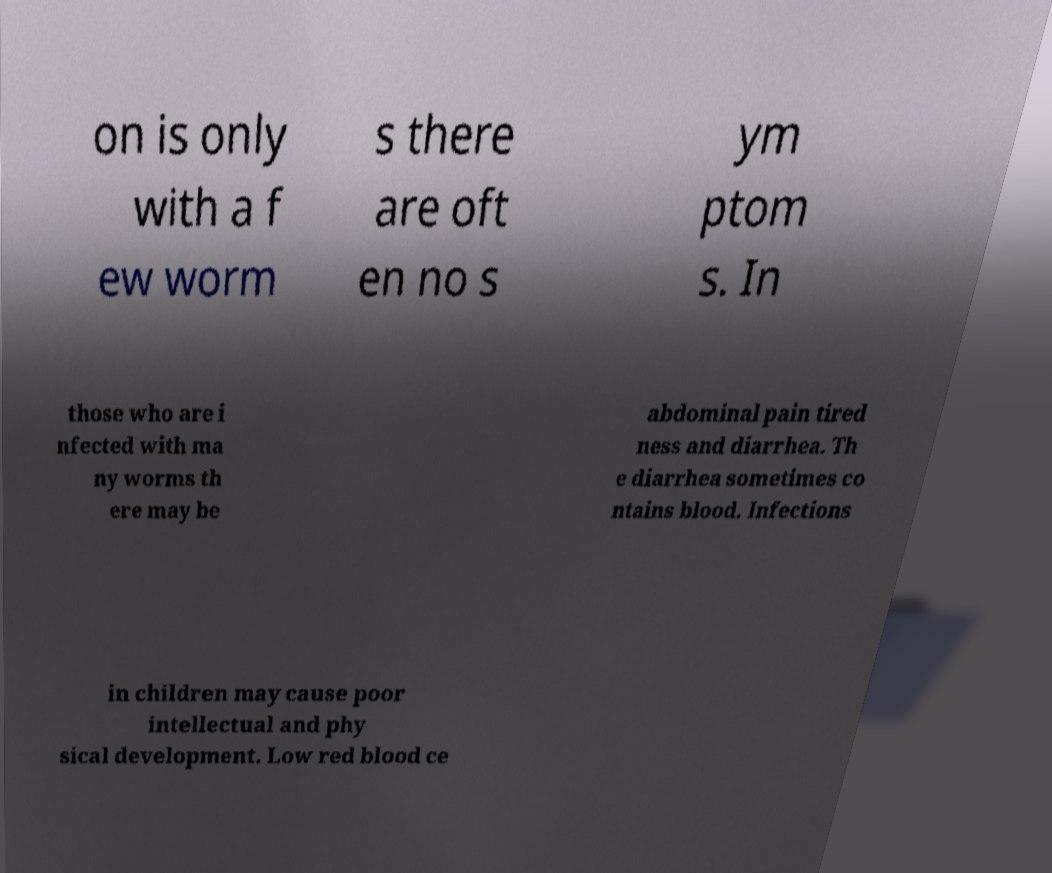For documentation purposes, I need the text within this image transcribed. Could you provide that? on is only with a f ew worm s there are oft en no s ym ptom s. In those who are i nfected with ma ny worms th ere may be abdominal pain tired ness and diarrhea. Th e diarrhea sometimes co ntains blood. Infections in children may cause poor intellectual and phy sical development. Low red blood ce 